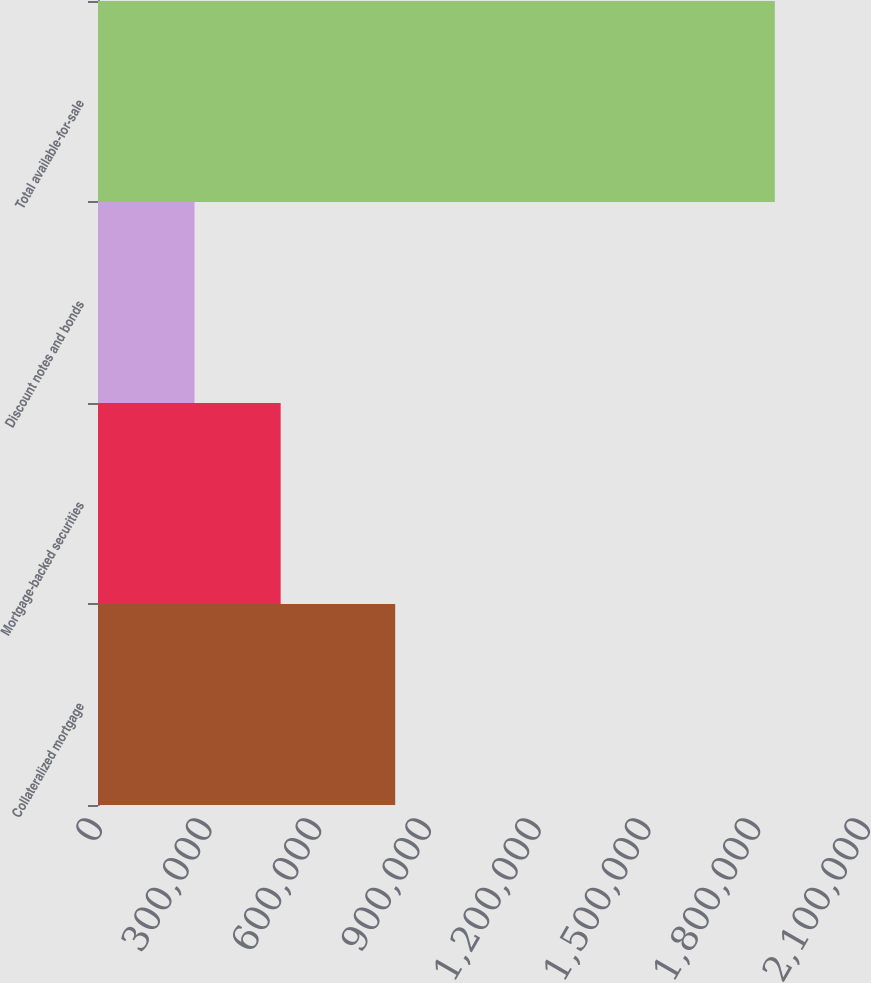Convert chart. <chart><loc_0><loc_0><loc_500><loc_500><bar_chart><fcel>Collateralized mortgage<fcel>Mortgage-backed securities<fcel>Discount notes and bonds<fcel>Total available-for-sale<nl><fcel>812644<fcel>499452<fcel>263894<fcel>1.85066e+06<nl></chart> 